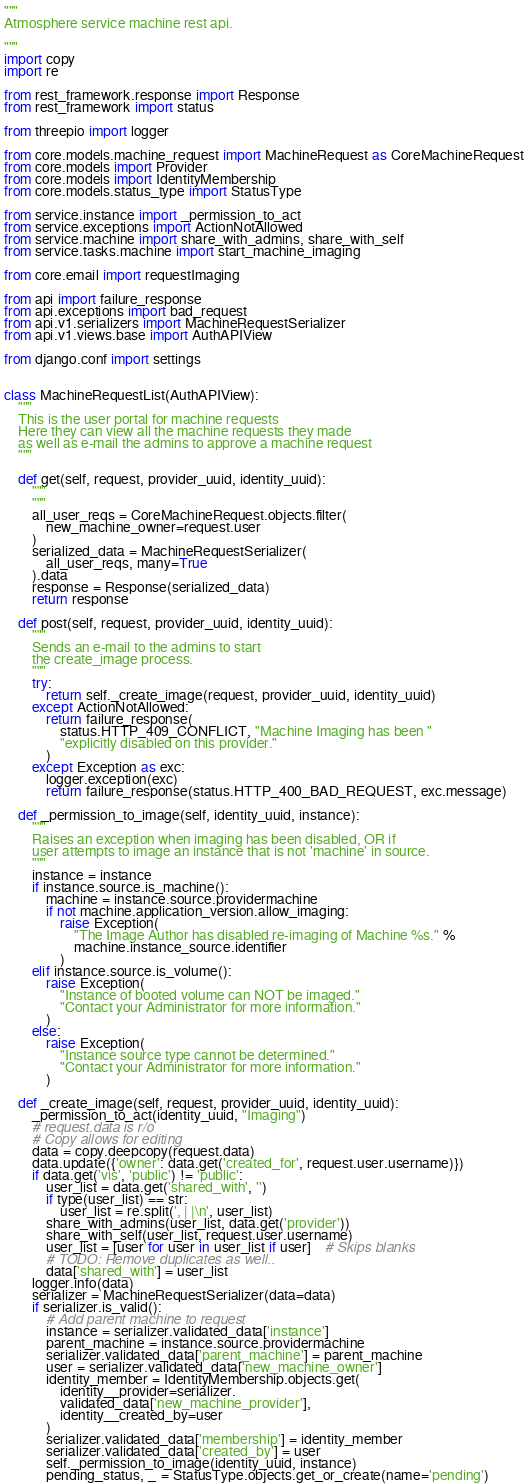<code> <loc_0><loc_0><loc_500><loc_500><_Python_>"""
Atmosphere service machine rest api.

"""
import copy
import re

from rest_framework.response import Response
from rest_framework import status

from threepio import logger

from core.models.machine_request import MachineRequest as CoreMachineRequest
from core.models import Provider
from core.models import IdentityMembership
from core.models.status_type import StatusType

from service.instance import _permission_to_act
from service.exceptions import ActionNotAllowed
from service.machine import share_with_admins, share_with_self
from service.tasks.machine import start_machine_imaging

from core.email import requestImaging

from api import failure_response
from api.exceptions import bad_request
from api.v1.serializers import MachineRequestSerializer
from api.v1.views.base import AuthAPIView

from django.conf import settings


class MachineRequestList(AuthAPIView):
    """
    This is the user portal for machine requests
    Here they can view all the machine requests they made
    as well as e-mail the admins to approve a machine request
    """

    def get(self, request, provider_uuid, identity_uuid):
        """
        """
        all_user_reqs = CoreMachineRequest.objects.filter(
            new_machine_owner=request.user
        )
        serialized_data = MachineRequestSerializer(
            all_user_reqs, many=True
        ).data
        response = Response(serialized_data)
        return response

    def post(self, request, provider_uuid, identity_uuid):
        """
        Sends an e-mail to the admins to start
        the create_image process.
        """
        try:
            return self._create_image(request, provider_uuid, identity_uuid)
        except ActionNotAllowed:
            return failure_response(
                status.HTTP_409_CONFLICT, "Machine Imaging has been "
                "explicitly disabled on this provider."
            )
        except Exception as exc:
            logger.exception(exc)
            return failure_response(status.HTTP_400_BAD_REQUEST, exc.message)

    def _permission_to_image(self, identity_uuid, instance):
        """
        Raises an exception when imaging has been disabled, OR if
        user attempts to image an instance that is not 'machine' in source.
        """
        instance = instance
        if instance.source.is_machine():
            machine = instance.source.providermachine
            if not machine.application_version.allow_imaging:
                raise Exception(
                    "The Image Author has disabled re-imaging of Machine %s." %
                    machine.instance_source.identifier
                )
        elif instance.source.is_volume():
            raise Exception(
                "Instance of booted volume can NOT be imaged."
                "Contact your Administrator for more information."
            )
        else:
            raise Exception(
                "Instance source type cannot be determined."
                "Contact your Administrator for more information."
            )

    def _create_image(self, request, provider_uuid, identity_uuid):
        _permission_to_act(identity_uuid, "Imaging")
        # request.data is r/o
        # Copy allows for editing
        data = copy.deepcopy(request.data)
        data.update({'owner': data.get('created_for', request.user.username)})
        if data.get('vis', 'public') != 'public':
            user_list = data.get('shared_with', '')
            if type(user_list) == str:
                user_list = re.split(', | |\n', user_list)
            share_with_admins(user_list, data.get('provider'))
            share_with_self(user_list, request.user.username)
            user_list = [user for user in user_list if user]    # Skips blanks
            # TODO: Remove duplicates as well..
            data['shared_with'] = user_list
        logger.info(data)
        serializer = MachineRequestSerializer(data=data)
        if serializer.is_valid():
            # Add parent machine to request
            instance = serializer.validated_data['instance']
            parent_machine = instance.source.providermachine
            serializer.validated_data['parent_machine'] = parent_machine
            user = serializer.validated_data['new_machine_owner']
            identity_member = IdentityMembership.objects.get(
                identity__provider=serializer.
                validated_data['new_machine_provider'],
                identity__created_by=user
            )
            serializer.validated_data['membership'] = identity_member
            serializer.validated_data['created_by'] = user
            self._permission_to_image(identity_uuid, instance)
            pending_status, _ = StatusType.objects.get_or_create(name='pending')</code> 